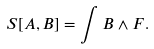Convert formula to latex. <formula><loc_0><loc_0><loc_500><loc_500>S [ A , B ] = \int B \wedge F .</formula> 